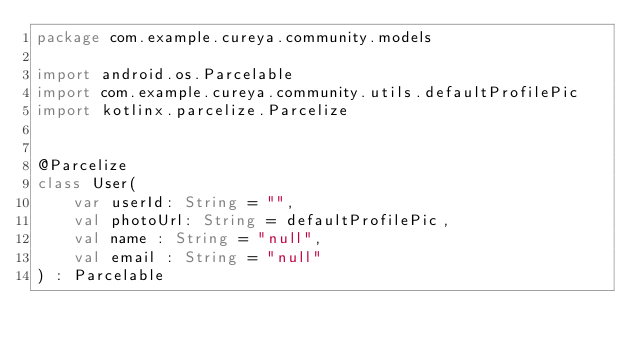<code> <loc_0><loc_0><loc_500><loc_500><_Kotlin_>package com.example.cureya.community.models

import android.os.Parcelable
import com.example.cureya.community.utils.defaultProfilePic
import kotlinx.parcelize.Parcelize


@Parcelize
class User(
    var userId: String = "",
    val photoUrl: String = defaultProfilePic,
    val name : String = "null",
    val email : String = "null"
) : Parcelable</code> 